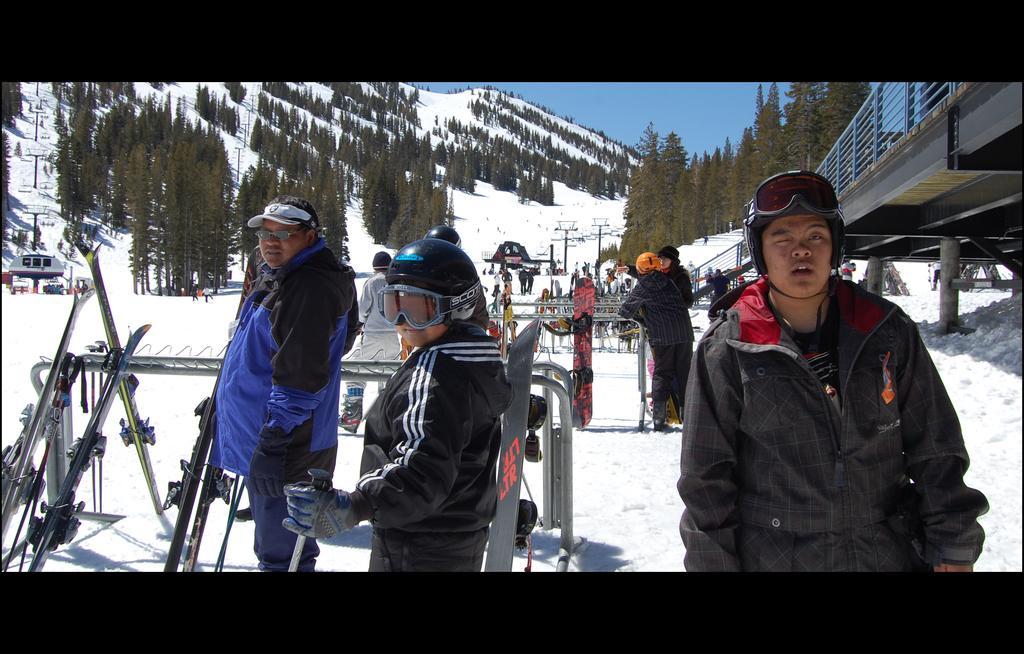Describe this image in one or two sentences. in this picture there are trees and ice on the ground, here is a person wearing a jacket and gloves, here is a person wearing glasses and holding a stick in his hand. and there are group of people. and the sky is cloudy, and here is the metal rod and here is the staircase, and a person wearing a jacket and standing. 